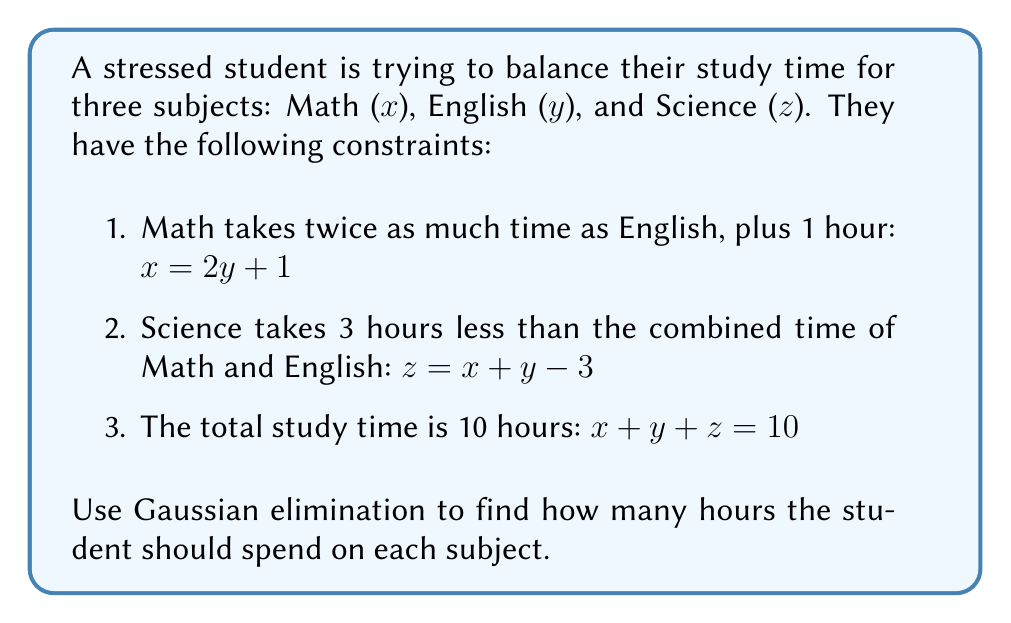Could you help me with this problem? Let's solve this system using Gaussian elimination:

1) First, we'll write our system of equations:
   $$\begin{aligned}
   x - 2y - 1 &= 0 \\
   x + y - z - 3 &= 0 \\
   x + y + z - 10 &= 0
   \end{aligned}$$

2) We'll create an augmented matrix:
   $$\begin{bmatrix}
   1 & -2 & 0 & -1 \\
   1 & 1 & -1 & -3 \\
   1 & 1 & 1 & 10
   \end{bmatrix}$$

3) Subtract row 1 from row 2 and row 3:
   $$\begin{bmatrix}
   1 & -2 & 0 & -1 \\
   0 & 3 & -1 & -2 \\
   0 & 3 & 1 & 11
   \end{bmatrix}$$

4) Subtract row 2 from row 3:
   $$\begin{bmatrix}
   1 & -2 & 0 & -1 \\
   0 & 3 & -1 & -2 \\
   0 & 0 & 2 & 13
   \end{bmatrix}$$

5) Now we have an upper triangular matrix. Let's solve for z:
   $2z = 13$
   $z = \frac{13}{2} = 6.5$

6) Substitute z into row 2:
   $3y - 6.5 = -2$
   $3y = 4.5$
   $y = 1.5$

7) Finally, substitute y and z into row 1:
   $x - 2(1.5) - 1 = 0$
   $x - 3 - 1 = 0$
   $x = 4$

Therefore, the student should spend 4 hours on Math, 1.5 hours on English, and 6.5 hours on Science.
Answer: Math: 4 hours, English: 1.5 hours, Science: 6.5 hours 